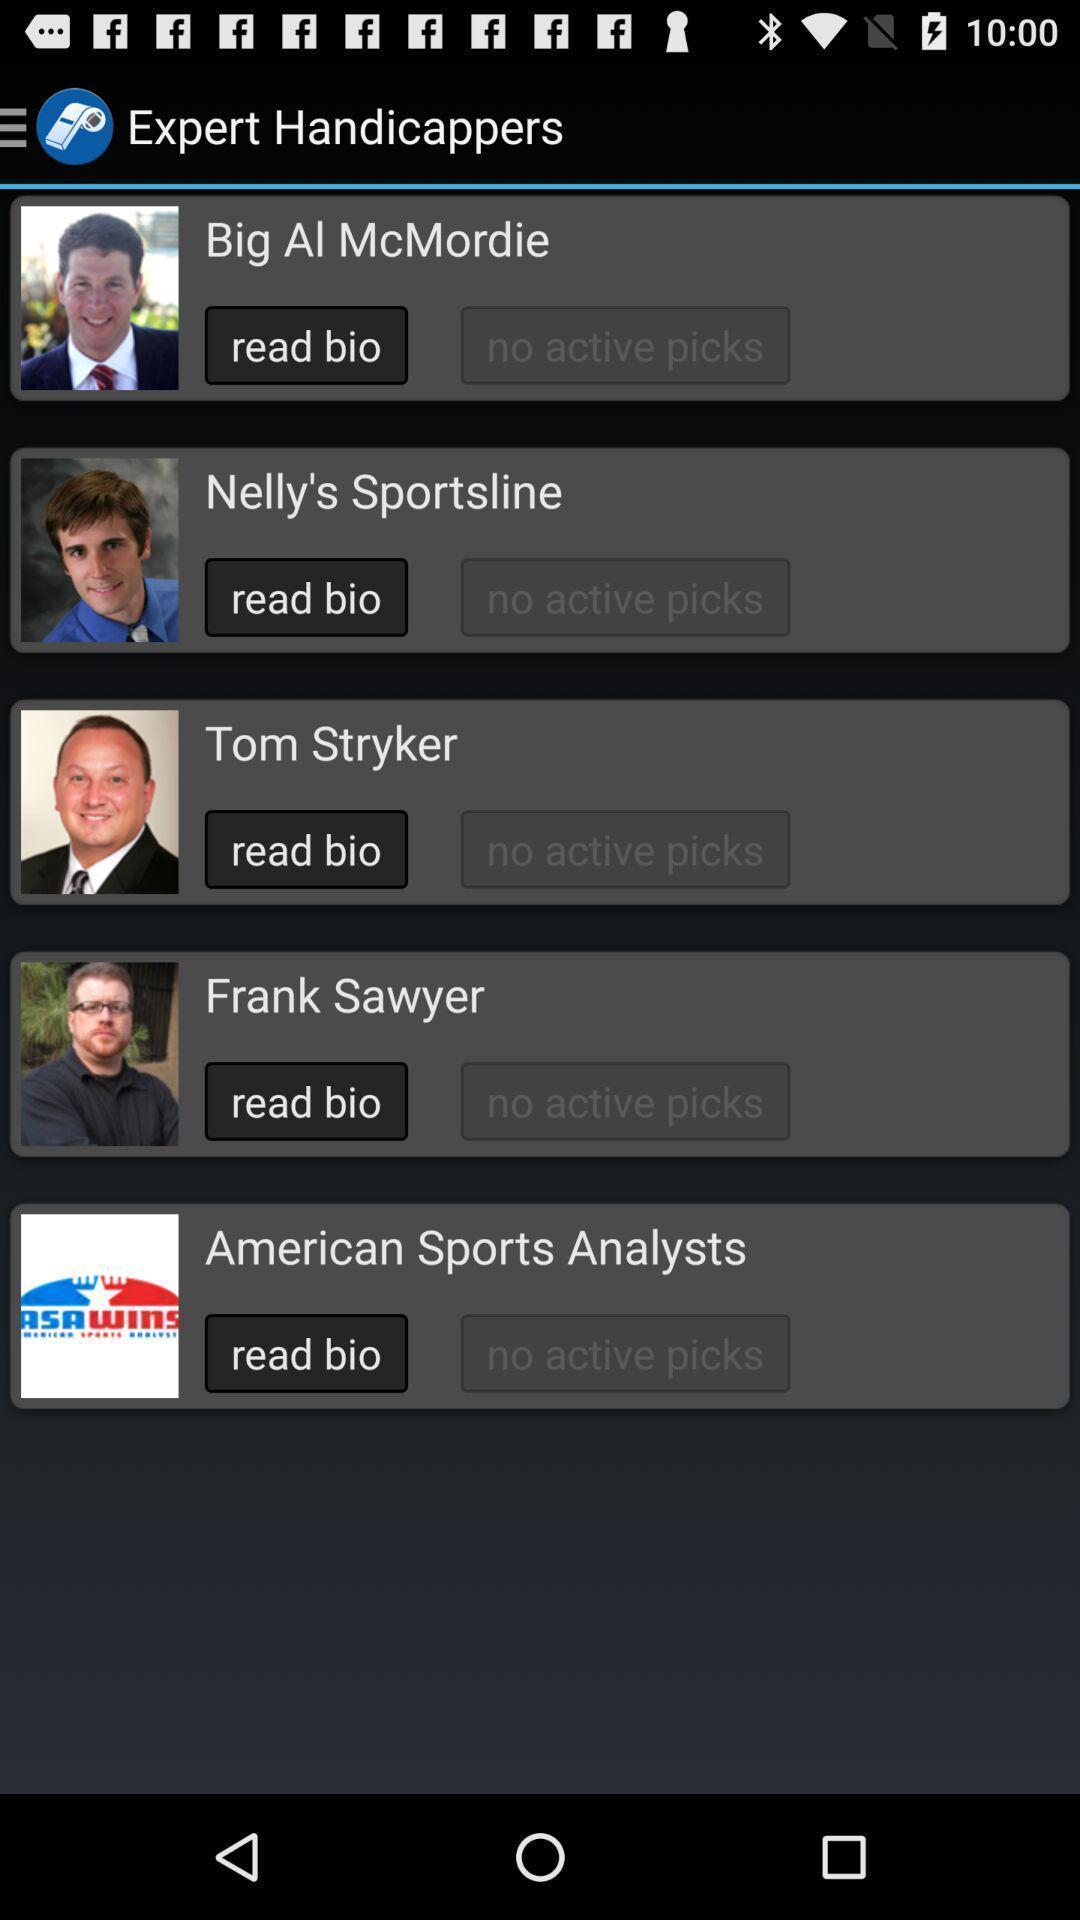Describe this image in words. Page shows the various team schedules. 